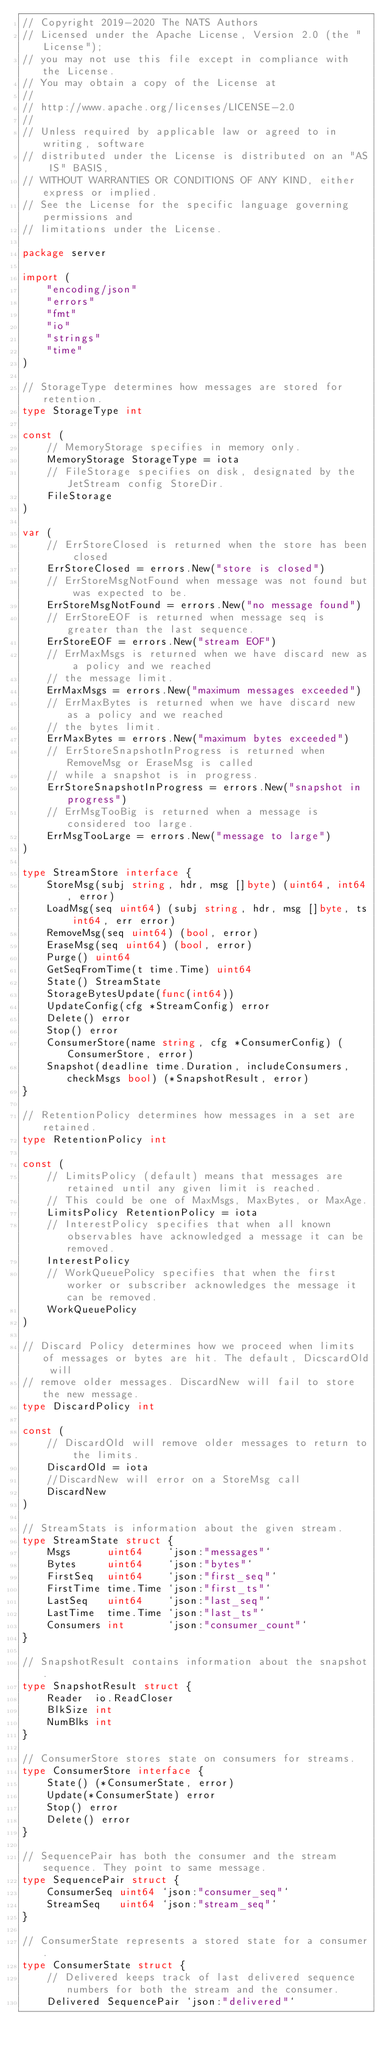<code> <loc_0><loc_0><loc_500><loc_500><_Go_>// Copyright 2019-2020 The NATS Authors
// Licensed under the Apache License, Version 2.0 (the "License");
// you may not use this file except in compliance with the License.
// You may obtain a copy of the License at
//
// http://www.apache.org/licenses/LICENSE-2.0
//
// Unless required by applicable law or agreed to in writing, software
// distributed under the License is distributed on an "AS IS" BASIS,
// WITHOUT WARRANTIES OR CONDITIONS OF ANY KIND, either express or implied.
// See the License for the specific language governing permissions and
// limitations under the License.

package server

import (
	"encoding/json"
	"errors"
	"fmt"
	"io"
	"strings"
	"time"
)

// StorageType determines how messages are stored for retention.
type StorageType int

const (
	// MemoryStorage specifies in memory only.
	MemoryStorage StorageType = iota
	// FileStorage specifies on disk, designated by the JetStream config StoreDir.
	FileStorage
)

var (
	// ErrStoreClosed is returned when the store has been closed
	ErrStoreClosed = errors.New("store is closed")
	// ErrStoreMsgNotFound when message was not found but was expected to be.
	ErrStoreMsgNotFound = errors.New("no message found")
	// ErrStoreEOF is returned when message seq is greater than the last sequence.
	ErrStoreEOF = errors.New("stream EOF")
	// ErrMaxMsgs is returned when we have discard new as a policy and we reached
	// the message limit.
	ErrMaxMsgs = errors.New("maximum messages exceeded")
	// ErrMaxBytes is returned when we have discard new as a policy and we reached
	// the bytes limit.
	ErrMaxBytes = errors.New("maximum bytes exceeded")
	// ErrStoreSnapshotInProgress is returned when RemoveMsg or EraseMsg is called
	// while a snapshot is in progress.
	ErrStoreSnapshotInProgress = errors.New("snapshot in progress")
	// ErrMsgTooBig is returned when a message is considered too large.
	ErrMsgTooLarge = errors.New("message to large")
)

type StreamStore interface {
	StoreMsg(subj string, hdr, msg []byte) (uint64, int64, error)
	LoadMsg(seq uint64) (subj string, hdr, msg []byte, ts int64, err error)
	RemoveMsg(seq uint64) (bool, error)
	EraseMsg(seq uint64) (bool, error)
	Purge() uint64
	GetSeqFromTime(t time.Time) uint64
	State() StreamState
	StorageBytesUpdate(func(int64))
	UpdateConfig(cfg *StreamConfig) error
	Delete() error
	Stop() error
	ConsumerStore(name string, cfg *ConsumerConfig) (ConsumerStore, error)
	Snapshot(deadline time.Duration, includeConsumers, checkMsgs bool) (*SnapshotResult, error)
}

// RetentionPolicy determines how messages in a set are retained.
type RetentionPolicy int

const (
	// LimitsPolicy (default) means that messages are retained until any given limit is reached.
	// This could be one of MaxMsgs, MaxBytes, or MaxAge.
	LimitsPolicy RetentionPolicy = iota
	// InterestPolicy specifies that when all known observables have acknowledged a message it can be removed.
	InterestPolicy
	// WorkQueuePolicy specifies that when the first worker or subscriber acknowledges the message it can be removed.
	WorkQueuePolicy
)

// Discard Policy determines how we proceed when limits of messages or bytes are hit. The default, DicscardOld will
// remove older messages. DiscardNew will fail to store the new message.
type DiscardPolicy int

const (
	// DiscardOld will remove older messages to return to the limits.
	DiscardOld = iota
	//DiscardNew will error on a StoreMsg call
	DiscardNew
)

// StreamStats is information about the given stream.
type StreamState struct {
	Msgs      uint64    `json:"messages"`
	Bytes     uint64    `json:"bytes"`
	FirstSeq  uint64    `json:"first_seq"`
	FirstTime time.Time `json:"first_ts"`
	LastSeq   uint64    `json:"last_seq"`
	LastTime  time.Time `json:"last_ts"`
	Consumers int       `json:"consumer_count"`
}

// SnapshotResult contains information about the snapshot.
type SnapshotResult struct {
	Reader  io.ReadCloser
	BlkSize int
	NumBlks int
}

// ConsumerStore stores state on consumers for streams.
type ConsumerStore interface {
	State() (*ConsumerState, error)
	Update(*ConsumerState) error
	Stop() error
	Delete() error
}

// SequencePair has both the consumer and the stream sequence. They point to same message.
type SequencePair struct {
	ConsumerSeq uint64 `json:"consumer_seq"`
	StreamSeq   uint64 `json:"stream_seq"`
}

// ConsumerState represents a stored state for a consumer.
type ConsumerState struct {
	// Delivered keeps track of last delivered sequence numbers for both the stream and the consumer.
	Delivered SequencePair `json:"delivered"`</code> 